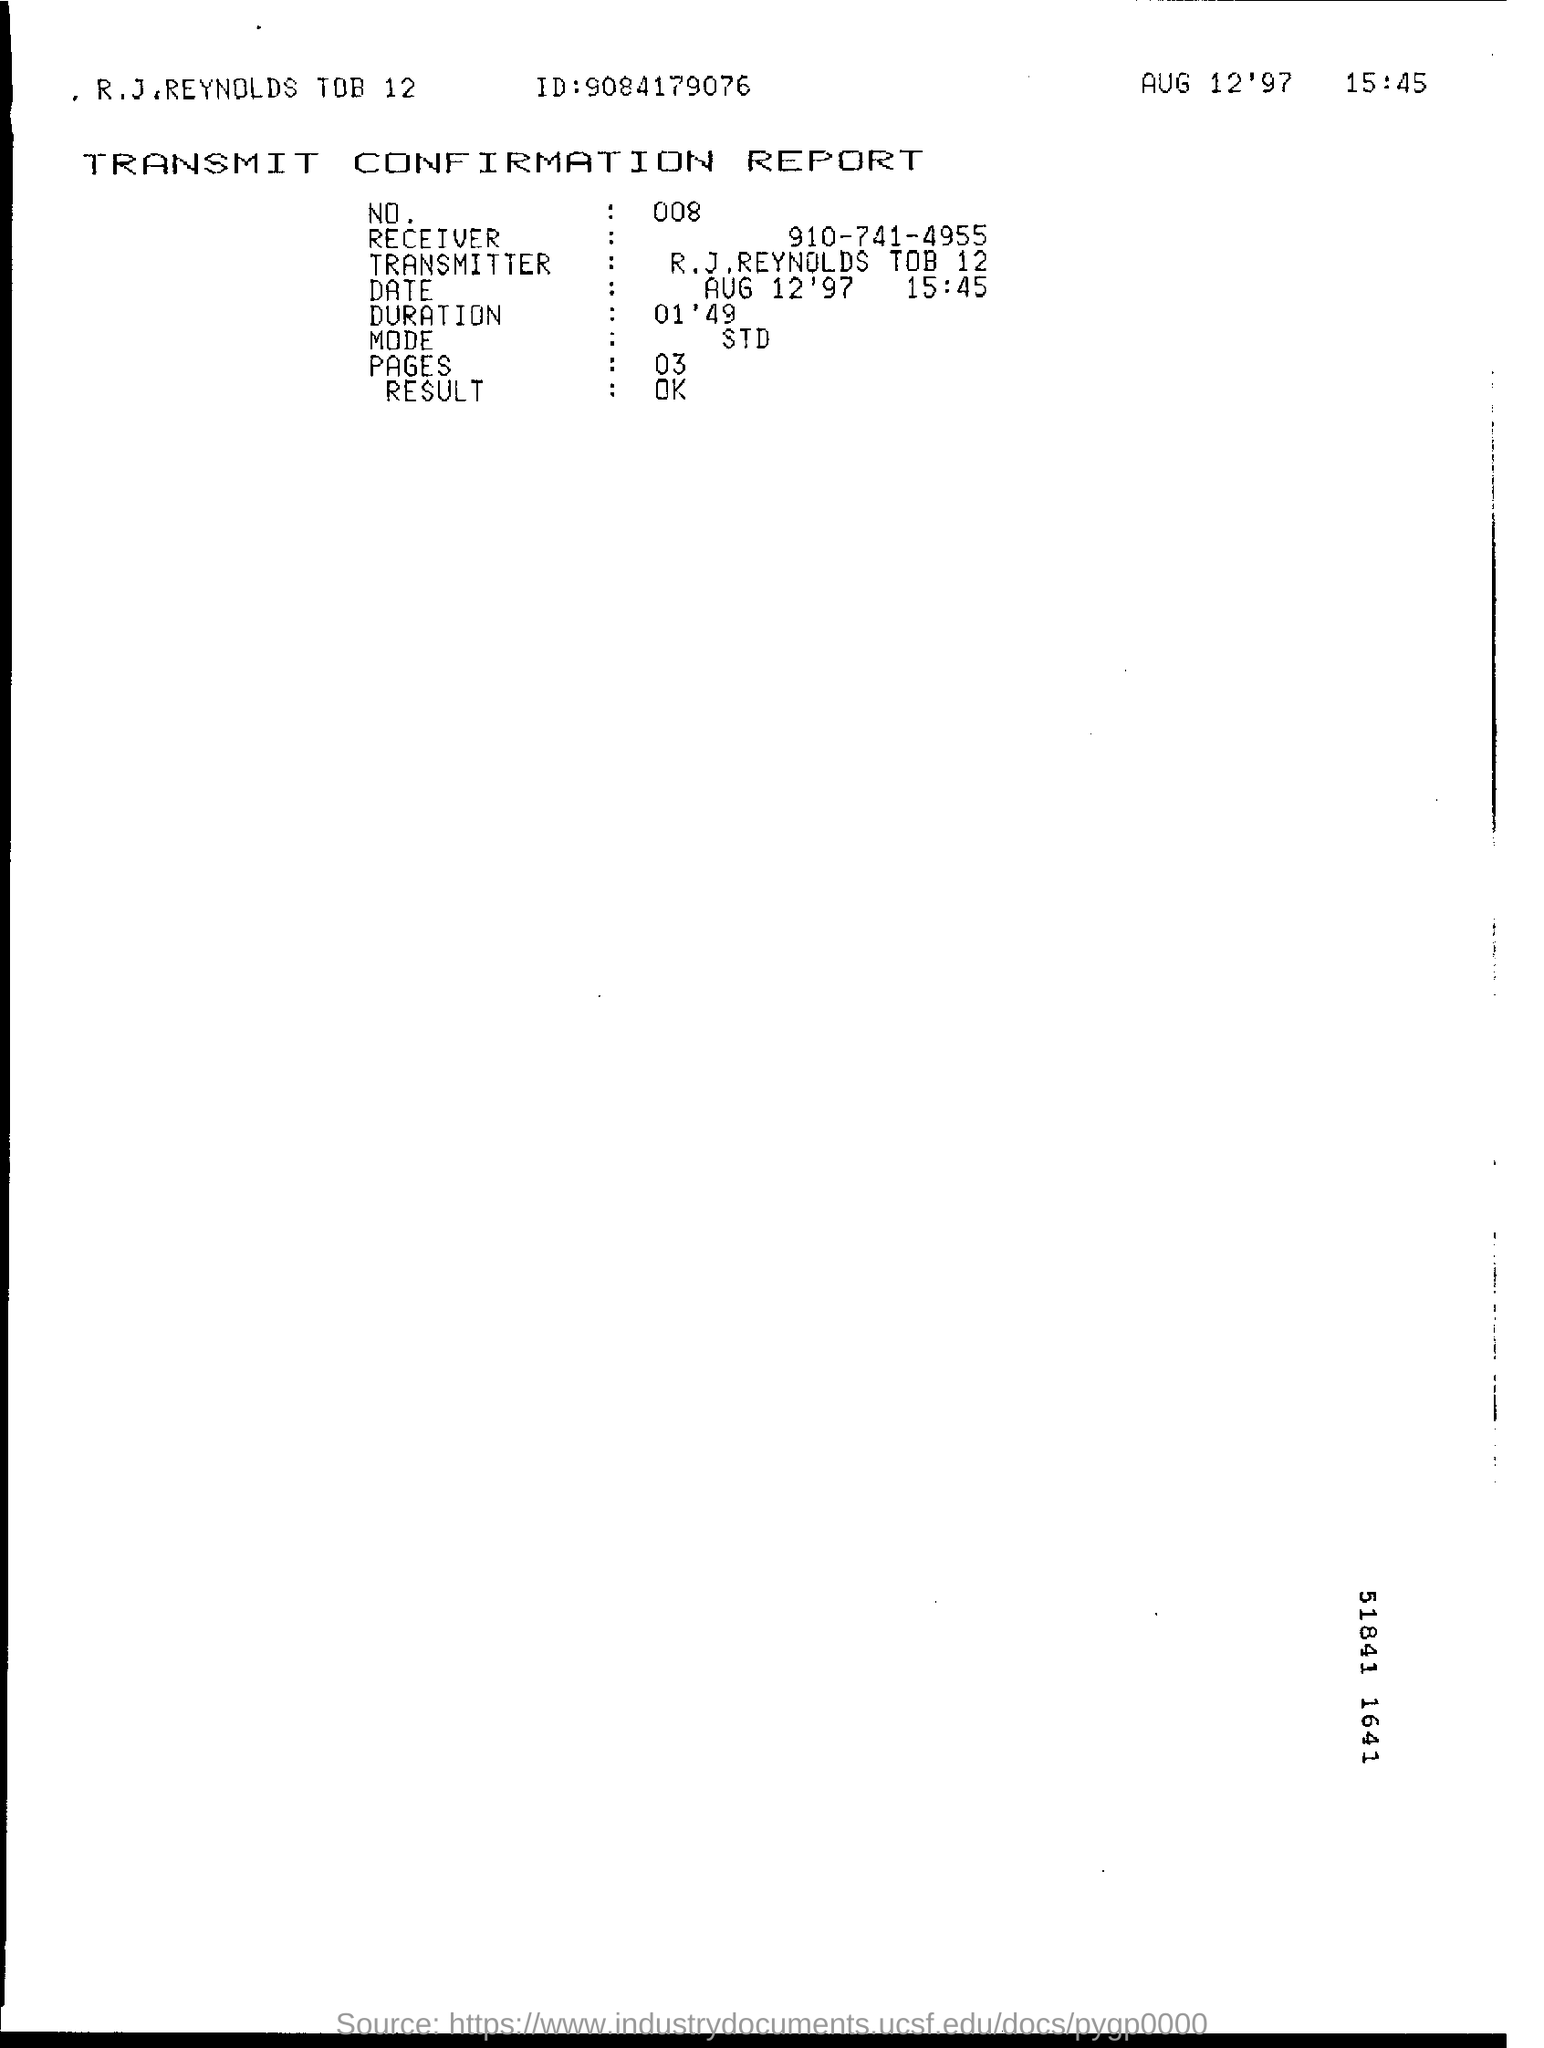Draw attention to some important aspects in this diagram. The number mentioned in the transmit confirmation report is 008. The fax transmission was sent on August 12, 1997, at 3:45 PM. The transmit confirmation report mentions the ID as 9084179076. The duration mentioned in the transmit confirmation report is 01'49.. 